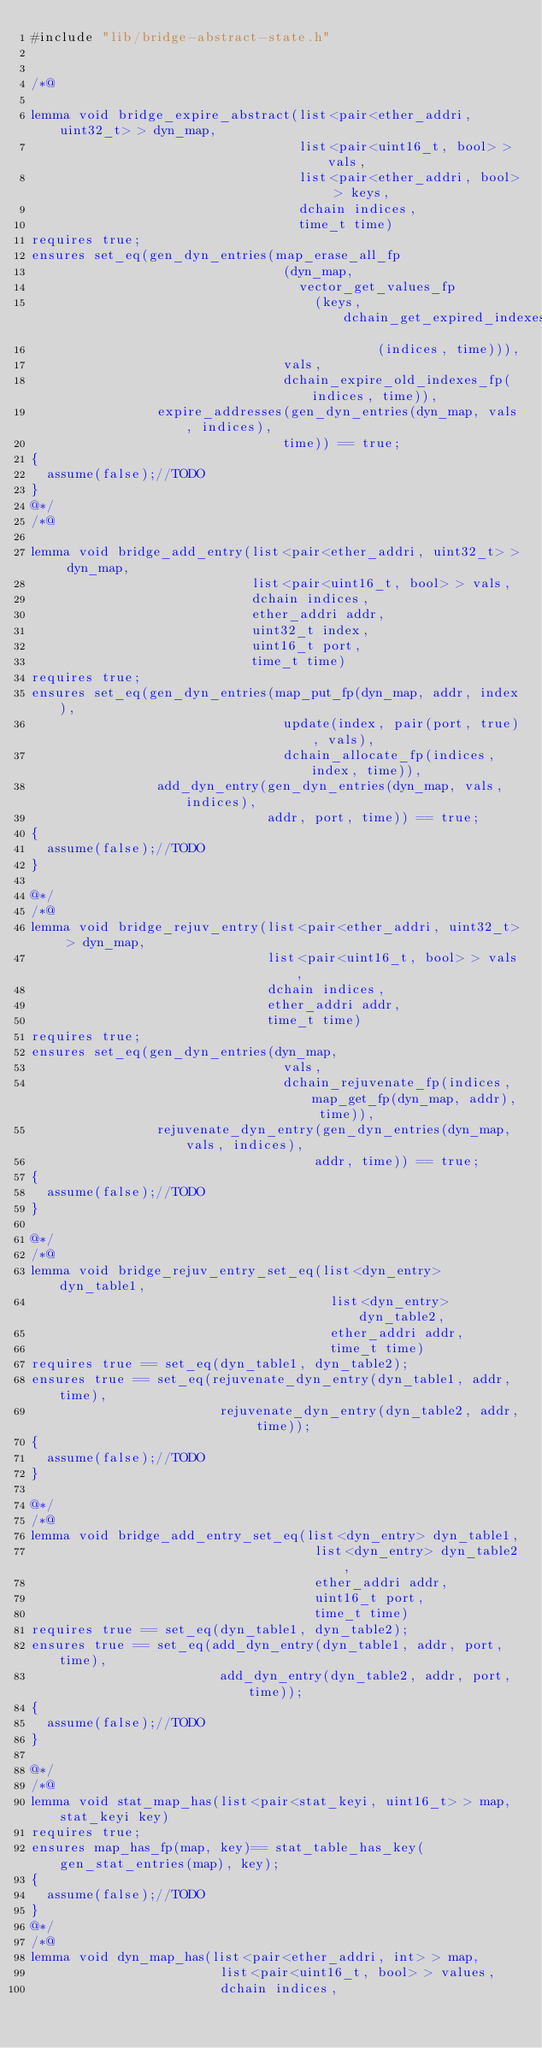Convert code to text. <code><loc_0><loc_0><loc_500><loc_500><_C_>#include "lib/bridge-abstract-state.h"


/*@

lemma void bridge_expire_abstract(list<pair<ether_addri, uint32_t> > dyn_map,
                                  list<pair<uint16_t, bool> > vals,
                                  list<pair<ether_addri, bool> > keys,
                                  dchain indices,
                                  time_t time)
requires true;
ensures set_eq(gen_dyn_entries(map_erase_all_fp
                                (dyn_map,
                                  vector_get_values_fp
                                    (keys, dchain_get_expired_indexes_fp
                                            (indices, time))),
                                vals,
                                dchain_expire_old_indexes_fp(indices, time)),
                expire_addresses(gen_dyn_entries(dyn_map, vals, indices),
                                time)) == true;
{
  assume(false);//TODO
}
@*/
/*@

lemma void bridge_add_entry(list<pair<ether_addri, uint32_t> > dyn_map,
                            list<pair<uint16_t, bool> > vals,
                            dchain indices,
                            ether_addri addr,
                            uint32_t index,
                            uint16_t port,
                            time_t time)
requires true;
ensures set_eq(gen_dyn_entries(map_put_fp(dyn_map, addr, index),
                                update(index, pair(port, true), vals),
                                dchain_allocate_fp(indices, index, time)),
                add_dyn_entry(gen_dyn_entries(dyn_map, vals, indices),
                              addr, port, time)) == true;
{
  assume(false);//TODO
}

@*/
/*@
lemma void bridge_rejuv_entry(list<pair<ether_addri, uint32_t> > dyn_map,
                              list<pair<uint16_t, bool> > vals,
                              dchain indices,
                              ether_addri addr,
                              time_t time)
requires true;
ensures set_eq(gen_dyn_entries(dyn_map,
                                vals,
                                dchain_rejuvenate_fp(indices, map_get_fp(dyn_map, addr), time)),
                rejuvenate_dyn_entry(gen_dyn_entries(dyn_map, vals, indices),
                                    addr, time)) == true;
{
  assume(false);//TODO
}

@*/
/*@
lemma void bridge_rejuv_entry_set_eq(list<dyn_entry> dyn_table1,
                                      list<dyn_entry> dyn_table2,
                                      ether_addri addr,
                                      time_t time)
requires true == set_eq(dyn_table1, dyn_table2);
ensures true == set_eq(rejuvenate_dyn_entry(dyn_table1, addr, time),
                        rejuvenate_dyn_entry(dyn_table2, addr, time));
{
  assume(false);//TODO
}

@*/
/*@
lemma void bridge_add_entry_set_eq(list<dyn_entry> dyn_table1,
                                    list<dyn_entry> dyn_table2,
                                    ether_addri addr,
                                    uint16_t port,
                                    time_t time)
requires true == set_eq(dyn_table1, dyn_table2);
ensures true == set_eq(add_dyn_entry(dyn_table1, addr, port, time),
                        add_dyn_entry(dyn_table2, addr, port, time));
{
  assume(false);//TODO
}

@*/
/*@
lemma void stat_map_has(list<pair<stat_keyi, uint16_t> > map, stat_keyi key)
requires true;
ensures map_has_fp(map, key)== stat_table_has_key(gen_stat_entries(map), key);
{
  assume(false);//TODO
}
@*/
/*@
lemma void dyn_map_has(list<pair<ether_addri, int> > map,
                        list<pair<uint16_t, bool> > values,
                        dchain indices,</code> 